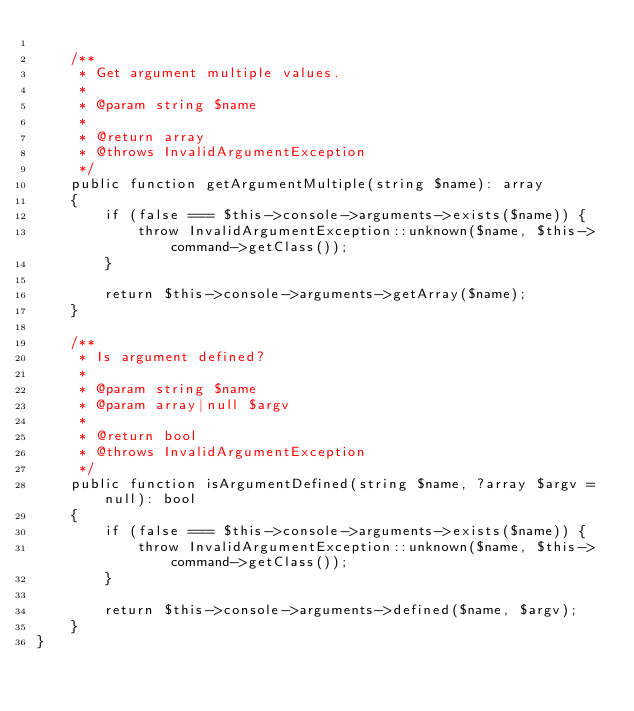<code> <loc_0><loc_0><loc_500><loc_500><_PHP_>
    /**
     * Get argument multiple values.
     *
     * @param string $name
     *
     * @return array
     * @throws InvalidArgumentException
     */
    public function getArgumentMultiple(string $name): array
    {
        if (false === $this->console->arguments->exists($name)) {
            throw InvalidArgumentException::unknown($name, $this->command->getClass());
        }

        return $this->console->arguments->getArray($name);
    }

    /**
     * Is argument defined?
     *
     * @param string $name
     * @param array|null $argv
     *
     * @return bool
     * @throws InvalidArgumentException
     */
    public function isArgumentDefined(string $name, ?array $argv = null): bool
    {
        if (false === $this->console->arguments->exists($name)) {
            throw InvalidArgumentException::unknown($name, $this->command->getClass());
        }

        return $this->console->arguments->defined($name, $argv);
    }
}</code> 